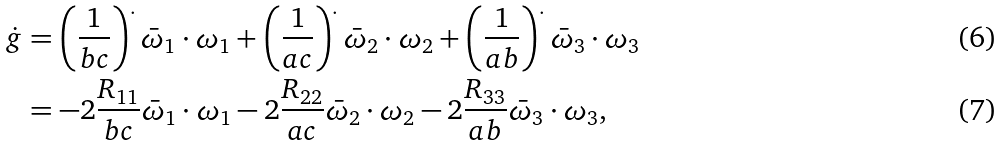<formula> <loc_0><loc_0><loc_500><loc_500>\dot { g } & = \left ( \frac { 1 } { b c } \right ) ^ { . } \bar { \omega } _ { 1 } \cdot \omega _ { 1 } + \left ( \frac { 1 } { a c } \right ) ^ { . } \bar { \omega } _ { 2 } \cdot \omega _ { 2 } + \left ( \frac { 1 } { a b } \right ) ^ { . } \bar { \omega } _ { 3 } \cdot \omega _ { 3 } \\ & = - 2 \frac { R _ { 1 1 } } { b c } \bar { \omega } _ { 1 } \cdot \omega _ { 1 } - 2 \frac { R _ { 2 2 } } { a c } \bar { \omega } _ { 2 } \cdot \omega _ { 2 } - 2 \frac { R _ { 3 3 } } { a b } \bar { \omega } _ { 3 } \cdot \omega _ { 3 } ,</formula> 